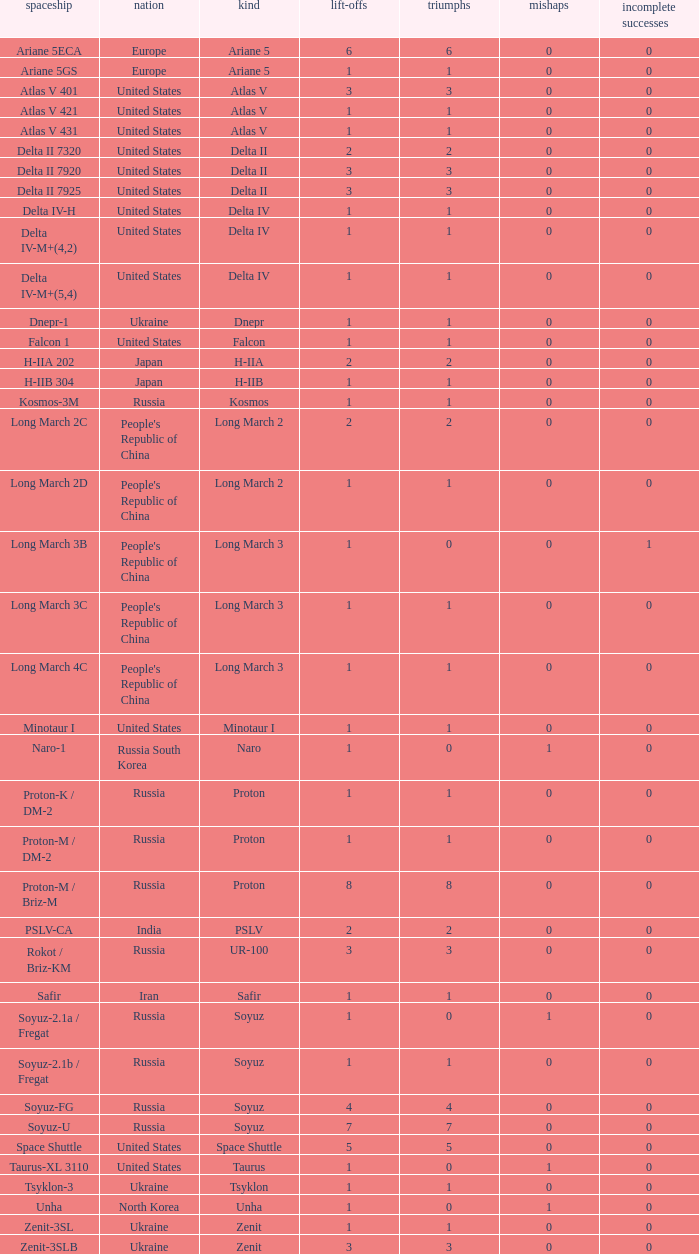What is the number of successes for rockets that have more than 3 launches, were based in Russia, are type soyuz and a rocket type of soyuz-u? 1.0. 